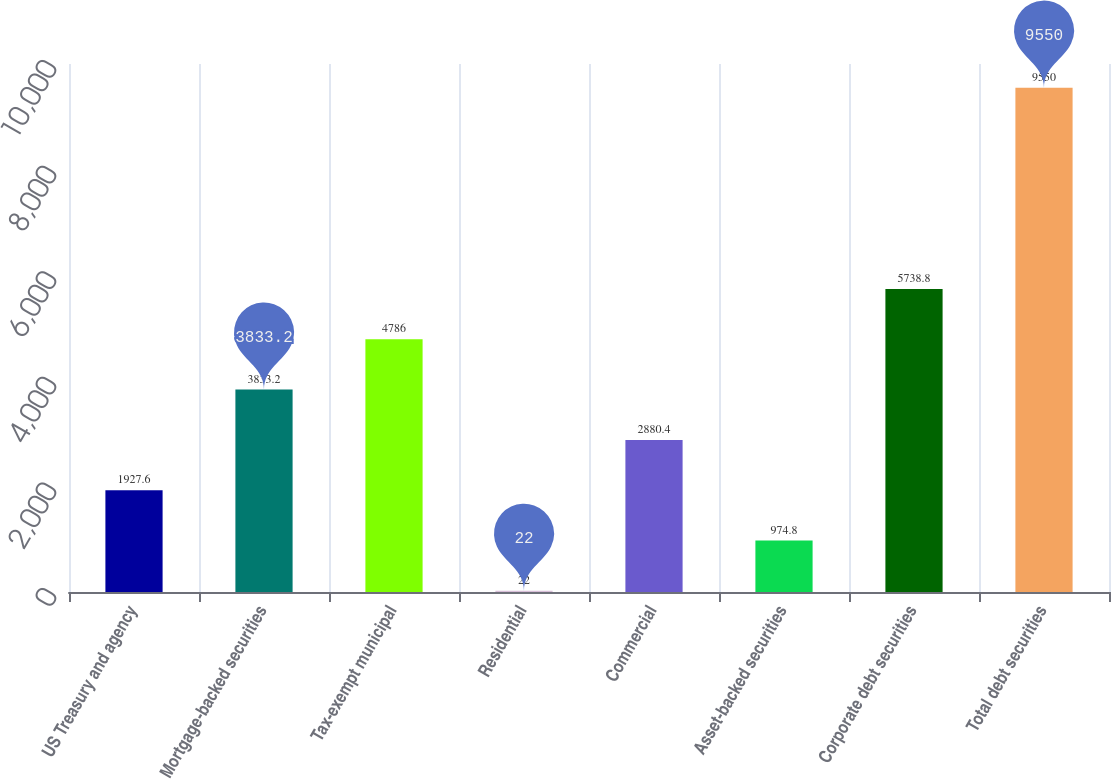<chart> <loc_0><loc_0><loc_500><loc_500><bar_chart><fcel>US Treasury and agency<fcel>Mortgage-backed securities<fcel>Tax-exempt municipal<fcel>Residential<fcel>Commercial<fcel>Asset-backed securities<fcel>Corporate debt securities<fcel>Total debt securities<nl><fcel>1927.6<fcel>3833.2<fcel>4786<fcel>22<fcel>2880.4<fcel>974.8<fcel>5738.8<fcel>9550<nl></chart> 